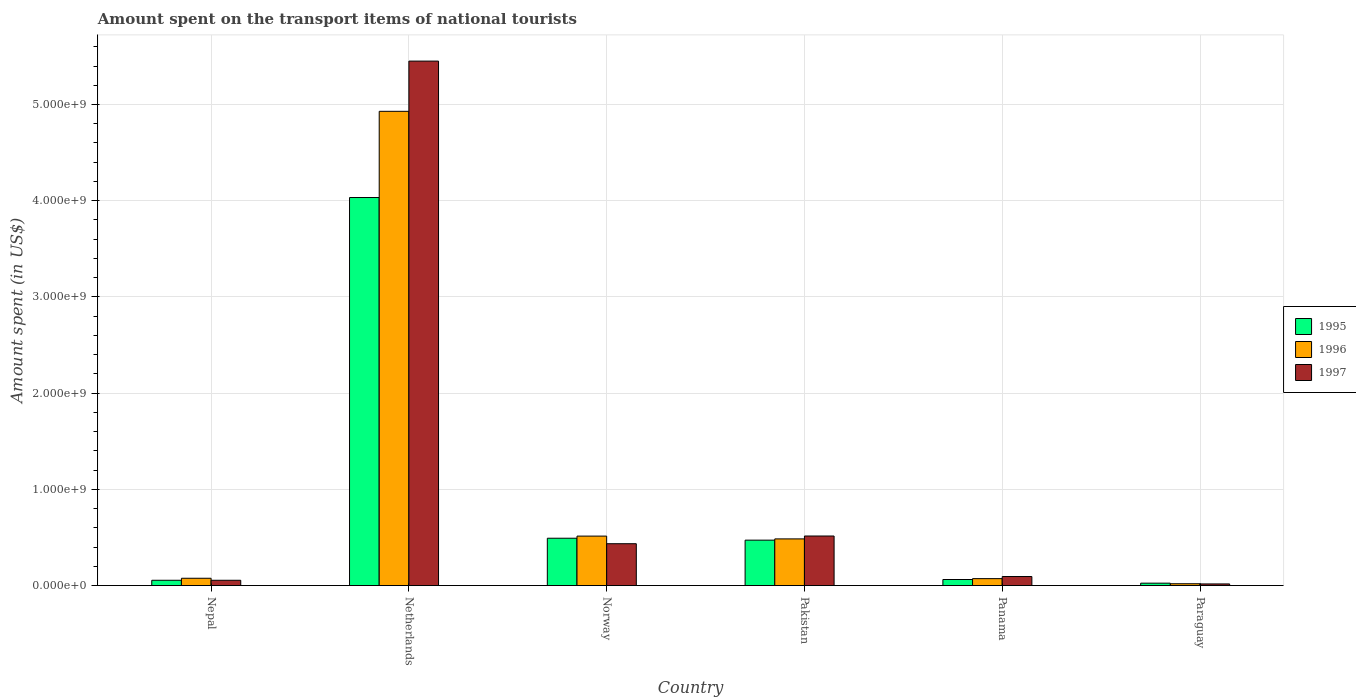How many different coloured bars are there?
Keep it short and to the point. 3. Are the number of bars per tick equal to the number of legend labels?
Provide a short and direct response. Yes. Are the number of bars on each tick of the X-axis equal?
Your answer should be very brief. Yes. What is the label of the 2nd group of bars from the left?
Offer a very short reply. Netherlands. In how many cases, is the number of bars for a given country not equal to the number of legend labels?
Offer a very short reply. 0. What is the amount spent on the transport items of national tourists in 1997 in Panama?
Provide a short and direct response. 9.40e+07. Across all countries, what is the maximum amount spent on the transport items of national tourists in 1997?
Your answer should be very brief. 5.45e+09. Across all countries, what is the minimum amount spent on the transport items of national tourists in 1997?
Your response must be concise. 1.70e+07. In which country was the amount spent on the transport items of national tourists in 1996 minimum?
Offer a very short reply. Paraguay. What is the total amount spent on the transport items of national tourists in 1995 in the graph?
Your answer should be very brief. 5.14e+09. What is the difference between the amount spent on the transport items of national tourists in 1995 in Nepal and that in Pakistan?
Give a very brief answer. -4.17e+08. What is the difference between the amount spent on the transport items of national tourists in 1997 in Norway and the amount spent on the transport items of national tourists in 1996 in Paraguay?
Your response must be concise. 4.16e+08. What is the average amount spent on the transport items of national tourists in 1995 per country?
Provide a succinct answer. 8.57e+08. What is the difference between the amount spent on the transport items of national tourists of/in 1995 and amount spent on the transport items of national tourists of/in 1997 in Panama?
Provide a short and direct response. -3.10e+07. In how many countries, is the amount spent on the transport items of national tourists in 1997 greater than 5400000000 US$?
Provide a succinct answer. 1. What is the ratio of the amount spent on the transport items of national tourists in 1996 in Nepal to that in Netherlands?
Offer a very short reply. 0.02. Is the amount spent on the transport items of national tourists in 1996 in Netherlands less than that in Paraguay?
Provide a short and direct response. No. What is the difference between the highest and the second highest amount spent on the transport items of national tourists in 1996?
Your response must be concise. 4.44e+09. What is the difference between the highest and the lowest amount spent on the transport items of national tourists in 1995?
Your answer should be compact. 4.01e+09. In how many countries, is the amount spent on the transport items of national tourists in 1995 greater than the average amount spent on the transport items of national tourists in 1995 taken over all countries?
Keep it short and to the point. 1. Is it the case that in every country, the sum of the amount spent on the transport items of national tourists in 1995 and amount spent on the transport items of national tourists in 1997 is greater than the amount spent on the transport items of national tourists in 1996?
Offer a terse response. Yes. What is the difference between two consecutive major ticks on the Y-axis?
Your answer should be compact. 1.00e+09. Are the values on the major ticks of Y-axis written in scientific E-notation?
Give a very brief answer. Yes. Does the graph contain any zero values?
Offer a very short reply. No. Where does the legend appear in the graph?
Your response must be concise. Center right. What is the title of the graph?
Make the answer very short. Amount spent on the transport items of national tourists. What is the label or title of the X-axis?
Ensure brevity in your answer.  Country. What is the label or title of the Y-axis?
Your answer should be very brief. Amount spent (in US$). What is the Amount spent (in US$) in 1995 in Nepal?
Offer a terse response. 5.50e+07. What is the Amount spent (in US$) in 1996 in Nepal?
Your response must be concise. 7.60e+07. What is the Amount spent (in US$) in 1997 in Nepal?
Make the answer very short. 5.50e+07. What is the Amount spent (in US$) in 1995 in Netherlands?
Keep it short and to the point. 4.03e+09. What is the Amount spent (in US$) of 1996 in Netherlands?
Your answer should be very brief. 4.93e+09. What is the Amount spent (in US$) of 1997 in Netherlands?
Give a very brief answer. 5.45e+09. What is the Amount spent (in US$) in 1995 in Norway?
Provide a succinct answer. 4.92e+08. What is the Amount spent (in US$) of 1996 in Norway?
Offer a very short reply. 5.14e+08. What is the Amount spent (in US$) of 1997 in Norway?
Your answer should be very brief. 4.35e+08. What is the Amount spent (in US$) in 1995 in Pakistan?
Your answer should be compact. 4.72e+08. What is the Amount spent (in US$) in 1996 in Pakistan?
Ensure brevity in your answer.  4.85e+08. What is the Amount spent (in US$) of 1997 in Pakistan?
Your answer should be very brief. 5.15e+08. What is the Amount spent (in US$) of 1995 in Panama?
Give a very brief answer. 6.30e+07. What is the Amount spent (in US$) of 1996 in Panama?
Your response must be concise. 7.20e+07. What is the Amount spent (in US$) of 1997 in Panama?
Give a very brief answer. 9.40e+07. What is the Amount spent (in US$) in 1995 in Paraguay?
Your response must be concise. 2.50e+07. What is the Amount spent (in US$) of 1996 in Paraguay?
Give a very brief answer. 1.90e+07. What is the Amount spent (in US$) in 1997 in Paraguay?
Ensure brevity in your answer.  1.70e+07. Across all countries, what is the maximum Amount spent (in US$) of 1995?
Offer a terse response. 4.03e+09. Across all countries, what is the maximum Amount spent (in US$) in 1996?
Make the answer very short. 4.93e+09. Across all countries, what is the maximum Amount spent (in US$) of 1997?
Offer a terse response. 5.45e+09. Across all countries, what is the minimum Amount spent (in US$) of 1995?
Offer a terse response. 2.50e+07. Across all countries, what is the minimum Amount spent (in US$) in 1996?
Provide a short and direct response. 1.90e+07. Across all countries, what is the minimum Amount spent (in US$) of 1997?
Your answer should be compact. 1.70e+07. What is the total Amount spent (in US$) of 1995 in the graph?
Your answer should be very brief. 5.14e+09. What is the total Amount spent (in US$) in 1996 in the graph?
Ensure brevity in your answer.  6.10e+09. What is the total Amount spent (in US$) of 1997 in the graph?
Keep it short and to the point. 6.57e+09. What is the difference between the Amount spent (in US$) in 1995 in Nepal and that in Netherlands?
Your response must be concise. -3.98e+09. What is the difference between the Amount spent (in US$) of 1996 in Nepal and that in Netherlands?
Provide a short and direct response. -4.85e+09. What is the difference between the Amount spent (in US$) in 1997 in Nepal and that in Netherlands?
Keep it short and to the point. -5.40e+09. What is the difference between the Amount spent (in US$) in 1995 in Nepal and that in Norway?
Provide a succinct answer. -4.37e+08. What is the difference between the Amount spent (in US$) in 1996 in Nepal and that in Norway?
Offer a terse response. -4.38e+08. What is the difference between the Amount spent (in US$) of 1997 in Nepal and that in Norway?
Keep it short and to the point. -3.80e+08. What is the difference between the Amount spent (in US$) of 1995 in Nepal and that in Pakistan?
Offer a very short reply. -4.17e+08. What is the difference between the Amount spent (in US$) in 1996 in Nepal and that in Pakistan?
Your answer should be compact. -4.09e+08. What is the difference between the Amount spent (in US$) of 1997 in Nepal and that in Pakistan?
Offer a terse response. -4.60e+08. What is the difference between the Amount spent (in US$) in 1995 in Nepal and that in Panama?
Give a very brief answer. -8.00e+06. What is the difference between the Amount spent (in US$) in 1997 in Nepal and that in Panama?
Offer a very short reply. -3.90e+07. What is the difference between the Amount spent (in US$) of 1995 in Nepal and that in Paraguay?
Your response must be concise. 3.00e+07. What is the difference between the Amount spent (in US$) of 1996 in Nepal and that in Paraguay?
Your answer should be very brief. 5.70e+07. What is the difference between the Amount spent (in US$) of 1997 in Nepal and that in Paraguay?
Your response must be concise. 3.80e+07. What is the difference between the Amount spent (in US$) of 1995 in Netherlands and that in Norway?
Your response must be concise. 3.54e+09. What is the difference between the Amount spent (in US$) of 1996 in Netherlands and that in Norway?
Provide a short and direct response. 4.42e+09. What is the difference between the Amount spent (in US$) of 1997 in Netherlands and that in Norway?
Your response must be concise. 5.02e+09. What is the difference between the Amount spent (in US$) of 1995 in Netherlands and that in Pakistan?
Offer a terse response. 3.56e+09. What is the difference between the Amount spent (in US$) in 1996 in Netherlands and that in Pakistan?
Keep it short and to the point. 4.44e+09. What is the difference between the Amount spent (in US$) in 1997 in Netherlands and that in Pakistan?
Offer a very short reply. 4.94e+09. What is the difference between the Amount spent (in US$) of 1995 in Netherlands and that in Panama?
Ensure brevity in your answer.  3.97e+09. What is the difference between the Amount spent (in US$) of 1996 in Netherlands and that in Panama?
Your answer should be very brief. 4.86e+09. What is the difference between the Amount spent (in US$) in 1997 in Netherlands and that in Panama?
Offer a very short reply. 5.36e+09. What is the difference between the Amount spent (in US$) in 1995 in Netherlands and that in Paraguay?
Provide a succinct answer. 4.01e+09. What is the difference between the Amount spent (in US$) in 1996 in Netherlands and that in Paraguay?
Your answer should be compact. 4.91e+09. What is the difference between the Amount spent (in US$) in 1997 in Netherlands and that in Paraguay?
Provide a short and direct response. 5.43e+09. What is the difference between the Amount spent (in US$) in 1995 in Norway and that in Pakistan?
Make the answer very short. 2.00e+07. What is the difference between the Amount spent (in US$) in 1996 in Norway and that in Pakistan?
Make the answer very short. 2.90e+07. What is the difference between the Amount spent (in US$) of 1997 in Norway and that in Pakistan?
Offer a very short reply. -8.00e+07. What is the difference between the Amount spent (in US$) in 1995 in Norway and that in Panama?
Keep it short and to the point. 4.29e+08. What is the difference between the Amount spent (in US$) of 1996 in Norway and that in Panama?
Provide a short and direct response. 4.42e+08. What is the difference between the Amount spent (in US$) of 1997 in Norway and that in Panama?
Your answer should be very brief. 3.41e+08. What is the difference between the Amount spent (in US$) in 1995 in Norway and that in Paraguay?
Provide a succinct answer. 4.67e+08. What is the difference between the Amount spent (in US$) of 1996 in Norway and that in Paraguay?
Your answer should be very brief. 4.95e+08. What is the difference between the Amount spent (in US$) in 1997 in Norway and that in Paraguay?
Keep it short and to the point. 4.18e+08. What is the difference between the Amount spent (in US$) in 1995 in Pakistan and that in Panama?
Provide a succinct answer. 4.09e+08. What is the difference between the Amount spent (in US$) in 1996 in Pakistan and that in Panama?
Provide a succinct answer. 4.13e+08. What is the difference between the Amount spent (in US$) of 1997 in Pakistan and that in Panama?
Make the answer very short. 4.21e+08. What is the difference between the Amount spent (in US$) in 1995 in Pakistan and that in Paraguay?
Offer a terse response. 4.47e+08. What is the difference between the Amount spent (in US$) in 1996 in Pakistan and that in Paraguay?
Provide a short and direct response. 4.66e+08. What is the difference between the Amount spent (in US$) in 1997 in Pakistan and that in Paraguay?
Your answer should be compact. 4.98e+08. What is the difference between the Amount spent (in US$) in 1995 in Panama and that in Paraguay?
Provide a short and direct response. 3.80e+07. What is the difference between the Amount spent (in US$) of 1996 in Panama and that in Paraguay?
Your response must be concise. 5.30e+07. What is the difference between the Amount spent (in US$) in 1997 in Panama and that in Paraguay?
Provide a succinct answer. 7.70e+07. What is the difference between the Amount spent (in US$) of 1995 in Nepal and the Amount spent (in US$) of 1996 in Netherlands?
Make the answer very short. -4.87e+09. What is the difference between the Amount spent (in US$) of 1995 in Nepal and the Amount spent (in US$) of 1997 in Netherlands?
Offer a terse response. -5.40e+09. What is the difference between the Amount spent (in US$) of 1996 in Nepal and the Amount spent (in US$) of 1997 in Netherlands?
Keep it short and to the point. -5.38e+09. What is the difference between the Amount spent (in US$) in 1995 in Nepal and the Amount spent (in US$) in 1996 in Norway?
Ensure brevity in your answer.  -4.59e+08. What is the difference between the Amount spent (in US$) of 1995 in Nepal and the Amount spent (in US$) of 1997 in Norway?
Ensure brevity in your answer.  -3.80e+08. What is the difference between the Amount spent (in US$) in 1996 in Nepal and the Amount spent (in US$) in 1997 in Norway?
Provide a succinct answer. -3.59e+08. What is the difference between the Amount spent (in US$) of 1995 in Nepal and the Amount spent (in US$) of 1996 in Pakistan?
Your answer should be very brief. -4.30e+08. What is the difference between the Amount spent (in US$) in 1995 in Nepal and the Amount spent (in US$) in 1997 in Pakistan?
Ensure brevity in your answer.  -4.60e+08. What is the difference between the Amount spent (in US$) of 1996 in Nepal and the Amount spent (in US$) of 1997 in Pakistan?
Provide a short and direct response. -4.39e+08. What is the difference between the Amount spent (in US$) of 1995 in Nepal and the Amount spent (in US$) of 1996 in Panama?
Provide a succinct answer. -1.70e+07. What is the difference between the Amount spent (in US$) in 1995 in Nepal and the Amount spent (in US$) in 1997 in Panama?
Ensure brevity in your answer.  -3.90e+07. What is the difference between the Amount spent (in US$) of 1996 in Nepal and the Amount spent (in US$) of 1997 in Panama?
Make the answer very short. -1.80e+07. What is the difference between the Amount spent (in US$) in 1995 in Nepal and the Amount spent (in US$) in 1996 in Paraguay?
Keep it short and to the point. 3.60e+07. What is the difference between the Amount spent (in US$) of 1995 in Nepal and the Amount spent (in US$) of 1997 in Paraguay?
Your answer should be very brief. 3.80e+07. What is the difference between the Amount spent (in US$) of 1996 in Nepal and the Amount spent (in US$) of 1997 in Paraguay?
Your response must be concise. 5.90e+07. What is the difference between the Amount spent (in US$) of 1995 in Netherlands and the Amount spent (in US$) of 1996 in Norway?
Keep it short and to the point. 3.52e+09. What is the difference between the Amount spent (in US$) of 1995 in Netherlands and the Amount spent (in US$) of 1997 in Norway?
Your answer should be compact. 3.60e+09. What is the difference between the Amount spent (in US$) in 1996 in Netherlands and the Amount spent (in US$) in 1997 in Norway?
Your answer should be compact. 4.49e+09. What is the difference between the Amount spent (in US$) of 1995 in Netherlands and the Amount spent (in US$) of 1996 in Pakistan?
Keep it short and to the point. 3.55e+09. What is the difference between the Amount spent (in US$) of 1995 in Netherlands and the Amount spent (in US$) of 1997 in Pakistan?
Keep it short and to the point. 3.52e+09. What is the difference between the Amount spent (in US$) in 1996 in Netherlands and the Amount spent (in US$) in 1997 in Pakistan?
Make the answer very short. 4.41e+09. What is the difference between the Amount spent (in US$) of 1995 in Netherlands and the Amount spent (in US$) of 1996 in Panama?
Provide a succinct answer. 3.96e+09. What is the difference between the Amount spent (in US$) of 1995 in Netherlands and the Amount spent (in US$) of 1997 in Panama?
Provide a short and direct response. 3.94e+09. What is the difference between the Amount spent (in US$) in 1996 in Netherlands and the Amount spent (in US$) in 1997 in Panama?
Make the answer very short. 4.84e+09. What is the difference between the Amount spent (in US$) in 1995 in Netherlands and the Amount spent (in US$) in 1996 in Paraguay?
Your answer should be very brief. 4.01e+09. What is the difference between the Amount spent (in US$) of 1995 in Netherlands and the Amount spent (in US$) of 1997 in Paraguay?
Your answer should be very brief. 4.02e+09. What is the difference between the Amount spent (in US$) of 1996 in Netherlands and the Amount spent (in US$) of 1997 in Paraguay?
Your response must be concise. 4.91e+09. What is the difference between the Amount spent (in US$) of 1995 in Norway and the Amount spent (in US$) of 1997 in Pakistan?
Your answer should be compact. -2.30e+07. What is the difference between the Amount spent (in US$) of 1996 in Norway and the Amount spent (in US$) of 1997 in Pakistan?
Make the answer very short. -1.00e+06. What is the difference between the Amount spent (in US$) in 1995 in Norway and the Amount spent (in US$) in 1996 in Panama?
Give a very brief answer. 4.20e+08. What is the difference between the Amount spent (in US$) of 1995 in Norway and the Amount spent (in US$) of 1997 in Panama?
Offer a terse response. 3.98e+08. What is the difference between the Amount spent (in US$) of 1996 in Norway and the Amount spent (in US$) of 1997 in Panama?
Ensure brevity in your answer.  4.20e+08. What is the difference between the Amount spent (in US$) of 1995 in Norway and the Amount spent (in US$) of 1996 in Paraguay?
Your answer should be compact. 4.73e+08. What is the difference between the Amount spent (in US$) of 1995 in Norway and the Amount spent (in US$) of 1997 in Paraguay?
Make the answer very short. 4.75e+08. What is the difference between the Amount spent (in US$) of 1996 in Norway and the Amount spent (in US$) of 1997 in Paraguay?
Ensure brevity in your answer.  4.97e+08. What is the difference between the Amount spent (in US$) in 1995 in Pakistan and the Amount spent (in US$) in 1996 in Panama?
Your answer should be very brief. 4.00e+08. What is the difference between the Amount spent (in US$) of 1995 in Pakistan and the Amount spent (in US$) of 1997 in Panama?
Make the answer very short. 3.78e+08. What is the difference between the Amount spent (in US$) of 1996 in Pakistan and the Amount spent (in US$) of 1997 in Panama?
Make the answer very short. 3.91e+08. What is the difference between the Amount spent (in US$) in 1995 in Pakistan and the Amount spent (in US$) in 1996 in Paraguay?
Offer a terse response. 4.53e+08. What is the difference between the Amount spent (in US$) of 1995 in Pakistan and the Amount spent (in US$) of 1997 in Paraguay?
Give a very brief answer. 4.55e+08. What is the difference between the Amount spent (in US$) in 1996 in Pakistan and the Amount spent (in US$) in 1997 in Paraguay?
Give a very brief answer. 4.68e+08. What is the difference between the Amount spent (in US$) of 1995 in Panama and the Amount spent (in US$) of 1996 in Paraguay?
Keep it short and to the point. 4.40e+07. What is the difference between the Amount spent (in US$) of 1995 in Panama and the Amount spent (in US$) of 1997 in Paraguay?
Keep it short and to the point. 4.60e+07. What is the difference between the Amount spent (in US$) of 1996 in Panama and the Amount spent (in US$) of 1997 in Paraguay?
Ensure brevity in your answer.  5.50e+07. What is the average Amount spent (in US$) of 1995 per country?
Keep it short and to the point. 8.57e+08. What is the average Amount spent (in US$) of 1996 per country?
Provide a succinct answer. 1.02e+09. What is the average Amount spent (in US$) in 1997 per country?
Provide a short and direct response. 1.09e+09. What is the difference between the Amount spent (in US$) of 1995 and Amount spent (in US$) of 1996 in Nepal?
Keep it short and to the point. -2.10e+07. What is the difference between the Amount spent (in US$) in 1995 and Amount spent (in US$) in 1997 in Nepal?
Make the answer very short. 0. What is the difference between the Amount spent (in US$) of 1996 and Amount spent (in US$) of 1997 in Nepal?
Your response must be concise. 2.10e+07. What is the difference between the Amount spent (in US$) of 1995 and Amount spent (in US$) of 1996 in Netherlands?
Your answer should be very brief. -8.96e+08. What is the difference between the Amount spent (in US$) of 1995 and Amount spent (in US$) of 1997 in Netherlands?
Offer a very short reply. -1.42e+09. What is the difference between the Amount spent (in US$) of 1996 and Amount spent (in US$) of 1997 in Netherlands?
Offer a terse response. -5.22e+08. What is the difference between the Amount spent (in US$) in 1995 and Amount spent (in US$) in 1996 in Norway?
Your answer should be compact. -2.20e+07. What is the difference between the Amount spent (in US$) of 1995 and Amount spent (in US$) of 1997 in Norway?
Make the answer very short. 5.70e+07. What is the difference between the Amount spent (in US$) in 1996 and Amount spent (in US$) in 1997 in Norway?
Keep it short and to the point. 7.90e+07. What is the difference between the Amount spent (in US$) in 1995 and Amount spent (in US$) in 1996 in Pakistan?
Offer a terse response. -1.30e+07. What is the difference between the Amount spent (in US$) in 1995 and Amount spent (in US$) in 1997 in Pakistan?
Make the answer very short. -4.30e+07. What is the difference between the Amount spent (in US$) of 1996 and Amount spent (in US$) of 1997 in Pakistan?
Make the answer very short. -3.00e+07. What is the difference between the Amount spent (in US$) of 1995 and Amount spent (in US$) of 1996 in Panama?
Provide a short and direct response. -9.00e+06. What is the difference between the Amount spent (in US$) of 1995 and Amount spent (in US$) of 1997 in Panama?
Make the answer very short. -3.10e+07. What is the difference between the Amount spent (in US$) in 1996 and Amount spent (in US$) in 1997 in Panama?
Ensure brevity in your answer.  -2.20e+07. What is the difference between the Amount spent (in US$) of 1996 and Amount spent (in US$) of 1997 in Paraguay?
Make the answer very short. 2.00e+06. What is the ratio of the Amount spent (in US$) in 1995 in Nepal to that in Netherlands?
Your answer should be very brief. 0.01. What is the ratio of the Amount spent (in US$) in 1996 in Nepal to that in Netherlands?
Make the answer very short. 0.02. What is the ratio of the Amount spent (in US$) in 1997 in Nepal to that in Netherlands?
Offer a very short reply. 0.01. What is the ratio of the Amount spent (in US$) of 1995 in Nepal to that in Norway?
Your answer should be very brief. 0.11. What is the ratio of the Amount spent (in US$) of 1996 in Nepal to that in Norway?
Ensure brevity in your answer.  0.15. What is the ratio of the Amount spent (in US$) in 1997 in Nepal to that in Norway?
Offer a very short reply. 0.13. What is the ratio of the Amount spent (in US$) in 1995 in Nepal to that in Pakistan?
Give a very brief answer. 0.12. What is the ratio of the Amount spent (in US$) in 1996 in Nepal to that in Pakistan?
Give a very brief answer. 0.16. What is the ratio of the Amount spent (in US$) of 1997 in Nepal to that in Pakistan?
Provide a succinct answer. 0.11. What is the ratio of the Amount spent (in US$) of 1995 in Nepal to that in Panama?
Your answer should be very brief. 0.87. What is the ratio of the Amount spent (in US$) in 1996 in Nepal to that in Panama?
Offer a terse response. 1.06. What is the ratio of the Amount spent (in US$) of 1997 in Nepal to that in Panama?
Ensure brevity in your answer.  0.59. What is the ratio of the Amount spent (in US$) in 1996 in Nepal to that in Paraguay?
Make the answer very short. 4. What is the ratio of the Amount spent (in US$) in 1997 in Nepal to that in Paraguay?
Provide a short and direct response. 3.24. What is the ratio of the Amount spent (in US$) in 1995 in Netherlands to that in Norway?
Offer a very short reply. 8.2. What is the ratio of the Amount spent (in US$) in 1996 in Netherlands to that in Norway?
Ensure brevity in your answer.  9.59. What is the ratio of the Amount spent (in US$) in 1997 in Netherlands to that in Norway?
Your answer should be compact. 12.53. What is the ratio of the Amount spent (in US$) of 1995 in Netherlands to that in Pakistan?
Provide a succinct answer. 8.54. What is the ratio of the Amount spent (in US$) in 1996 in Netherlands to that in Pakistan?
Ensure brevity in your answer.  10.16. What is the ratio of the Amount spent (in US$) of 1997 in Netherlands to that in Pakistan?
Your answer should be compact. 10.58. What is the ratio of the Amount spent (in US$) in 1995 in Netherlands to that in Panama?
Offer a very short reply. 64.02. What is the ratio of the Amount spent (in US$) in 1996 in Netherlands to that in Panama?
Provide a short and direct response. 68.46. What is the ratio of the Amount spent (in US$) in 1997 in Netherlands to that in Panama?
Your response must be concise. 57.99. What is the ratio of the Amount spent (in US$) of 1995 in Netherlands to that in Paraguay?
Provide a succinct answer. 161.32. What is the ratio of the Amount spent (in US$) in 1996 in Netherlands to that in Paraguay?
Provide a short and direct response. 259.42. What is the ratio of the Amount spent (in US$) in 1997 in Netherlands to that in Paraguay?
Provide a short and direct response. 320.65. What is the ratio of the Amount spent (in US$) in 1995 in Norway to that in Pakistan?
Your response must be concise. 1.04. What is the ratio of the Amount spent (in US$) of 1996 in Norway to that in Pakistan?
Ensure brevity in your answer.  1.06. What is the ratio of the Amount spent (in US$) of 1997 in Norway to that in Pakistan?
Provide a short and direct response. 0.84. What is the ratio of the Amount spent (in US$) in 1995 in Norway to that in Panama?
Your answer should be compact. 7.81. What is the ratio of the Amount spent (in US$) in 1996 in Norway to that in Panama?
Provide a short and direct response. 7.14. What is the ratio of the Amount spent (in US$) of 1997 in Norway to that in Panama?
Make the answer very short. 4.63. What is the ratio of the Amount spent (in US$) of 1995 in Norway to that in Paraguay?
Make the answer very short. 19.68. What is the ratio of the Amount spent (in US$) in 1996 in Norway to that in Paraguay?
Provide a succinct answer. 27.05. What is the ratio of the Amount spent (in US$) in 1997 in Norway to that in Paraguay?
Give a very brief answer. 25.59. What is the ratio of the Amount spent (in US$) in 1995 in Pakistan to that in Panama?
Offer a terse response. 7.49. What is the ratio of the Amount spent (in US$) of 1996 in Pakistan to that in Panama?
Offer a terse response. 6.74. What is the ratio of the Amount spent (in US$) of 1997 in Pakistan to that in Panama?
Keep it short and to the point. 5.48. What is the ratio of the Amount spent (in US$) of 1995 in Pakistan to that in Paraguay?
Offer a terse response. 18.88. What is the ratio of the Amount spent (in US$) of 1996 in Pakistan to that in Paraguay?
Provide a short and direct response. 25.53. What is the ratio of the Amount spent (in US$) in 1997 in Pakistan to that in Paraguay?
Provide a succinct answer. 30.29. What is the ratio of the Amount spent (in US$) of 1995 in Panama to that in Paraguay?
Provide a short and direct response. 2.52. What is the ratio of the Amount spent (in US$) of 1996 in Panama to that in Paraguay?
Keep it short and to the point. 3.79. What is the ratio of the Amount spent (in US$) of 1997 in Panama to that in Paraguay?
Keep it short and to the point. 5.53. What is the difference between the highest and the second highest Amount spent (in US$) of 1995?
Offer a very short reply. 3.54e+09. What is the difference between the highest and the second highest Amount spent (in US$) of 1996?
Make the answer very short. 4.42e+09. What is the difference between the highest and the second highest Amount spent (in US$) of 1997?
Ensure brevity in your answer.  4.94e+09. What is the difference between the highest and the lowest Amount spent (in US$) of 1995?
Give a very brief answer. 4.01e+09. What is the difference between the highest and the lowest Amount spent (in US$) of 1996?
Keep it short and to the point. 4.91e+09. What is the difference between the highest and the lowest Amount spent (in US$) in 1997?
Your response must be concise. 5.43e+09. 